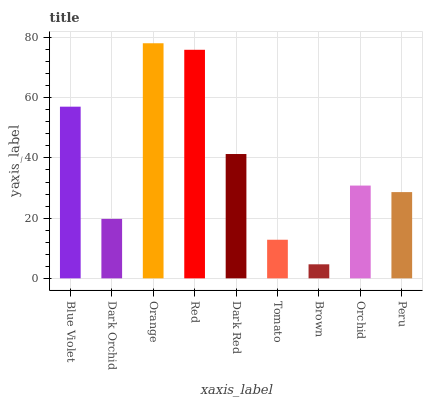Is Brown the minimum?
Answer yes or no. Yes. Is Orange the maximum?
Answer yes or no. Yes. Is Dark Orchid the minimum?
Answer yes or no. No. Is Dark Orchid the maximum?
Answer yes or no. No. Is Blue Violet greater than Dark Orchid?
Answer yes or no. Yes. Is Dark Orchid less than Blue Violet?
Answer yes or no. Yes. Is Dark Orchid greater than Blue Violet?
Answer yes or no. No. Is Blue Violet less than Dark Orchid?
Answer yes or no. No. Is Orchid the high median?
Answer yes or no. Yes. Is Orchid the low median?
Answer yes or no. Yes. Is Orange the high median?
Answer yes or no. No. Is Peru the low median?
Answer yes or no. No. 